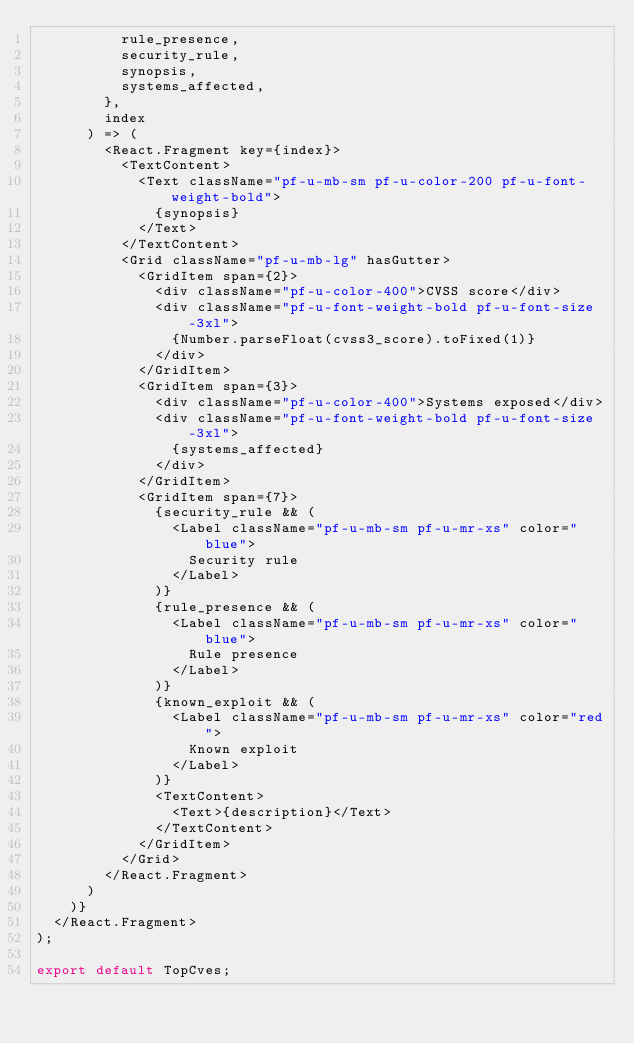Convert code to text. <code><loc_0><loc_0><loc_500><loc_500><_TypeScript_>          rule_presence,
          security_rule,
          synopsis,
          systems_affected,
        },
        index
      ) => (
        <React.Fragment key={index}>
          <TextContent>
            <Text className="pf-u-mb-sm pf-u-color-200 pf-u-font-weight-bold">
              {synopsis}
            </Text>
          </TextContent>
          <Grid className="pf-u-mb-lg" hasGutter>
            <GridItem span={2}>
              <div className="pf-u-color-400">CVSS score</div>
              <div className="pf-u-font-weight-bold pf-u-font-size-3xl">
                {Number.parseFloat(cvss3_score).toFixed(1)}
              </div>
            </GridItem>
            <GridItem span={3}>
              <div className="pf-u-color-400">Systems exposed</div>
              <div className="pf-u-font-weight-bold pf-u-font-size-3xl">
                {systems_affected}
              </div>
            </GridItem>
            <GridItem span={7}>
              {security_rule && (
                <Label className="pf-u-mb-sm pf-u-mr-xs" color="blue">
                  Security rule
                </Label>
              )}
              {rule_presence && (
                <Label className="pf-u-mb-sm pf-u-mr-xs" color="blue">
                  Rule presence
                </Label>
              )}
              {known_exploit && (
                <Label className="pf-u-mb-sm pf-u-mr-xs" color="red">
                  Known exploit
                </Label>
              )}
              <TextContent>
                <Text>{description}</Text>
              </TextContent>
            </GridItem>
          </Grid>
        </React.Fragment>
      )
    )}
  </React.Fragment>
);

export default TopCves;
</code> 